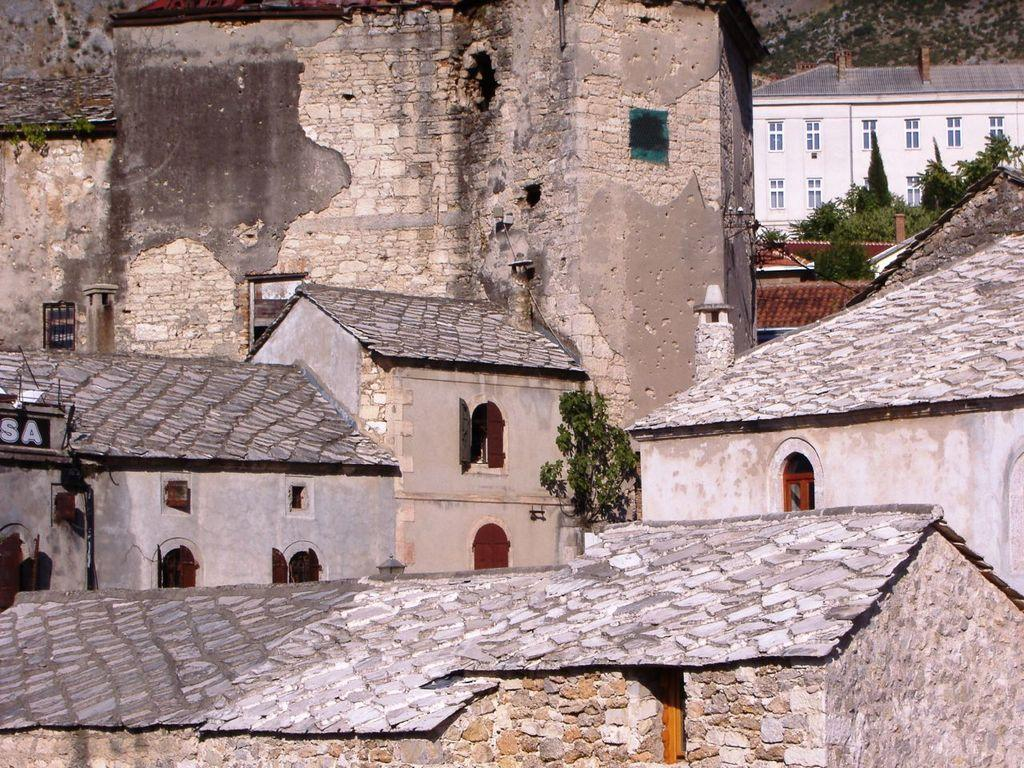What type of structures are present in the image? There are houses in the image. What features can be seen on the houses? The houses have windows and roofs. What type of vegetation is visible in the image? There are trees in the image. What is the material of the wall at the bottom of the image? The wall at the bottom of the image is made of bricks. How many frogs are sitting on the roofs of the houses in the image? There are no frogs present in the image; it only features houses, trees, and a brick wall. What type of apples can be seen growing on the trees in the image? There are no apples visible in the image; the trees are not specified as fruit-bearing trees. 